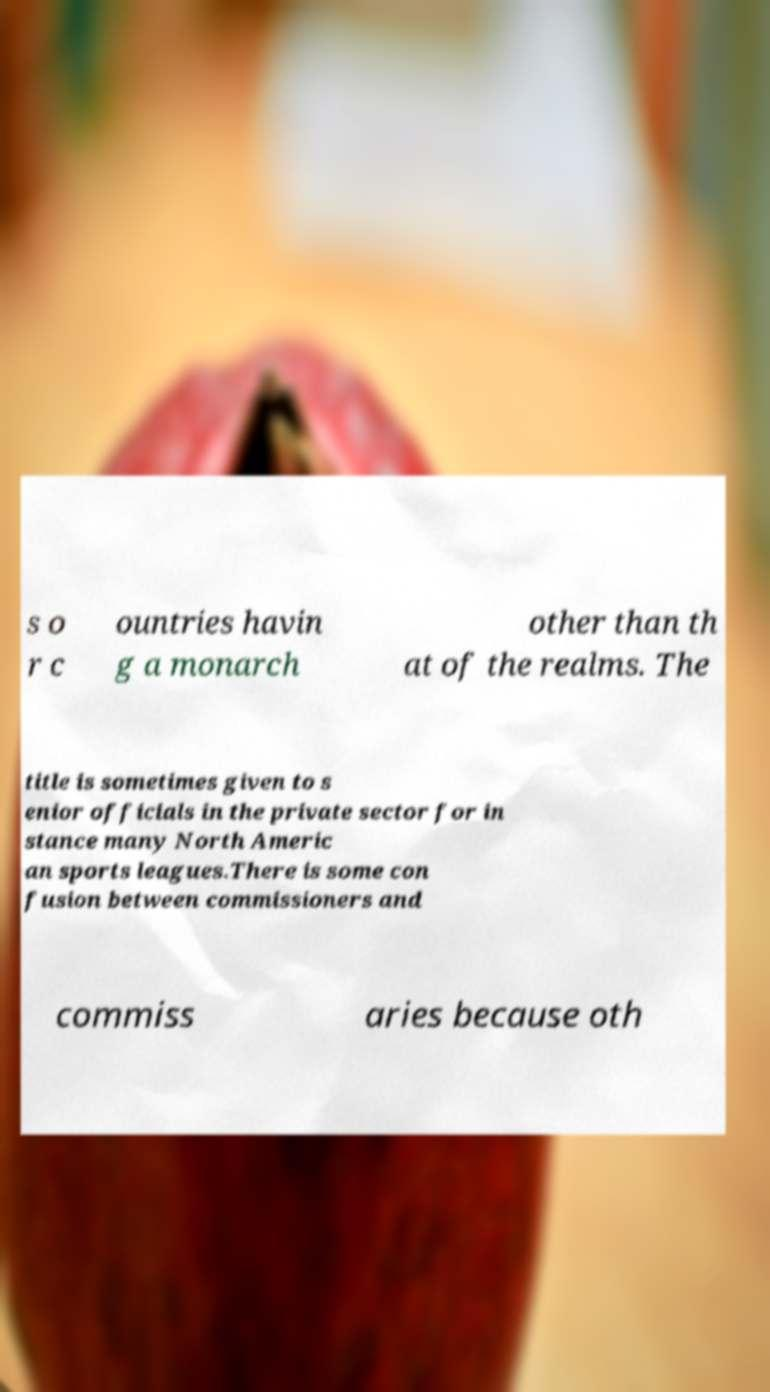Can you read and provide the text displayed in the image?This photo seems to have some interesting text. Can you extract and type it out for me? s o r c ountries havin g a monarch other than th at of the realms. The title is sometimes given to s enior officials in the private sector for in stance many North Americ an sports leagues.There is some con fusion between commissioners and commiss aries because oth 